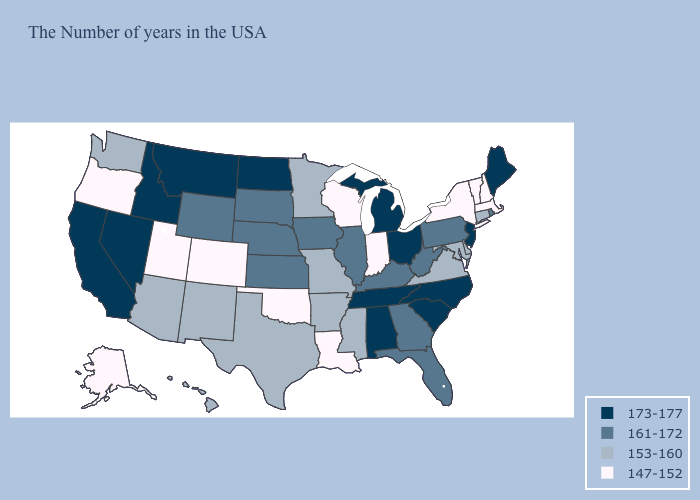Does the first symbol in the legend represent the smallest category?
Write a very short answer. No. Does Oklahoma have the highest value in the USA?
Answer briefly. No. Name the states that have a value in the range 161-172?
Give a very brief answer. Rhode Island, Pennsylvania, West Virginia, Florida, Georgia, Kentucky, Illinois, Iowa, Kansas, Nebraska, South Dakota, Wyoming. What is the lowest value in the USA?
Keep it brief. 147-152. What is the value of Michigan?
Be succinct. 173-177. Does Oklahoma have the lowest value in the South?
Give a very brief answer. Yes. Which states hav the highest value in the MidWest?
Write a very short answer. Ohio, Michigan, North Dakota. Name the states that have a value in the range 173-177?
Be succinct. Maine, New Jersey, North Carolina, South Carolina, Ohio, Michigan, Alabama, Tennessee, North Dakota, Montana, Idaho, Nevada, California. Name the states that have a value in the range 147-152?
Write a very short answer. Massachusetts, New Hampshire, Vermont, New York, Indiana, Wisconsin, Louisiana, Oklahoma, Colorado, Utah, Oregon, Alaska. Which states hav the highest value in the South?
Answer briefly. North Carolina, South Carolina, Alabama, Tennessee. What is the value of Nebraska?
Concise answer only. 161-172. How many symbols are there in the legend?
Write a very short answer. 4. Among the states that border Georgia , does Florida have the highest value?
Keep it brief. No. Does Oregon have the lowest value in the West?
Concise answer only. Yes. What is the value of Texas?
Be succinct. 153-160. 